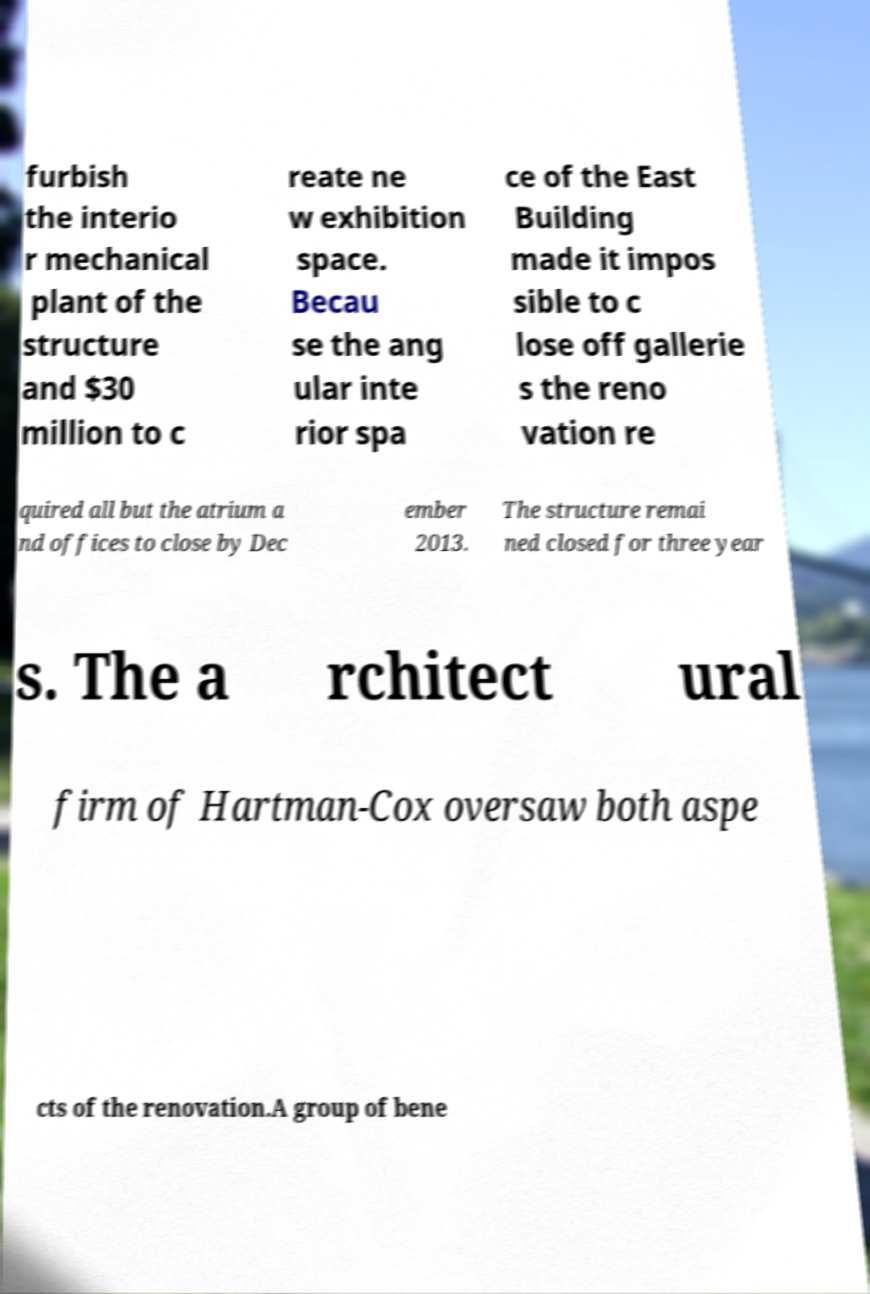For documentation purposes, I need the text within this image transcribed. Could you provide that? furbish the interio r mechanical plant of the structure and $30 million to c reate ne w exhibition space. Becau se the ang ular inte rior spa ce of the East Building made it impos sible to c lose off gallerie s the reno vation re quired all but the atrium a nd offices to close by Dec ember 2013. The structure remai ned closed for three year s. The a rchitect ural firm of Hartman-Cox oversaw both aspe cts of the renovation.A group of bene 